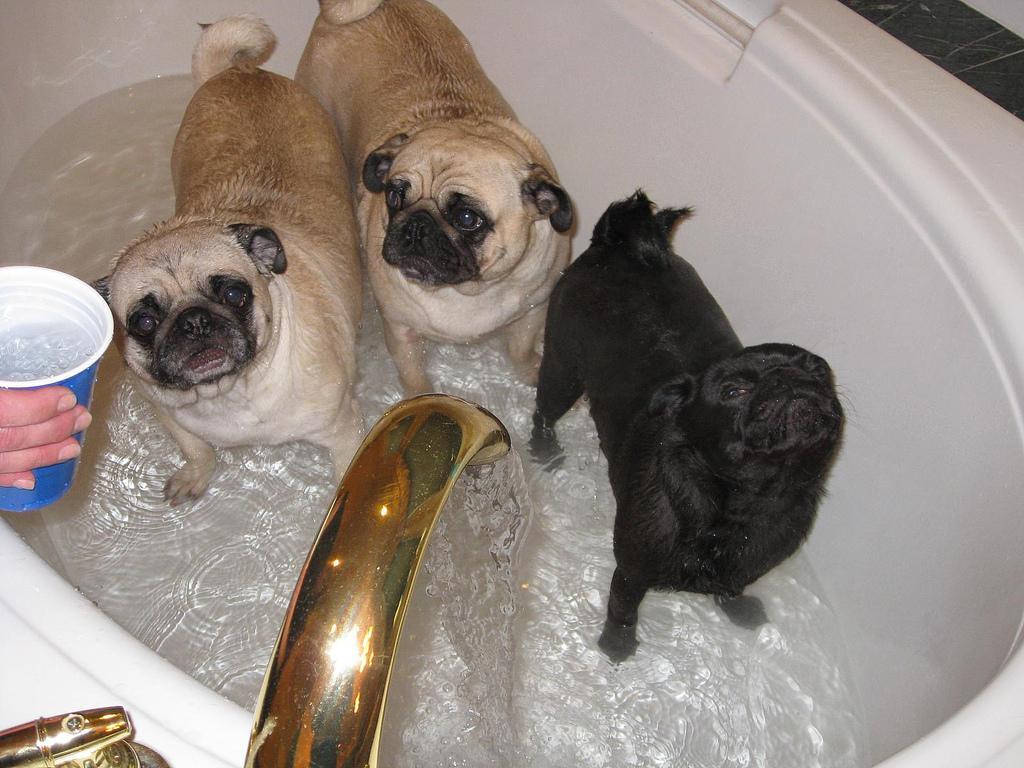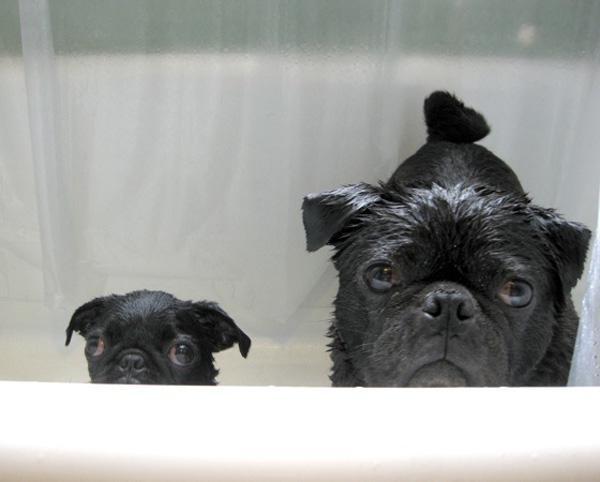The first image is the image on the left, the second image is the image on the right. For the images displayed, is the sentence "there are 4 dogs bathing in the image pair" factually correct? Answer yes or no. No. The first image is the image on the left, the second image is the image on the right. Evaluate the accuracy of this statement regarding the images: "One dog has soap on his back.". Is it true? Answer yes or no. No. 